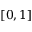<formula> <loc_0><loc_0><loc_500><loc_500>[ 0 , 1 ]</formula> 